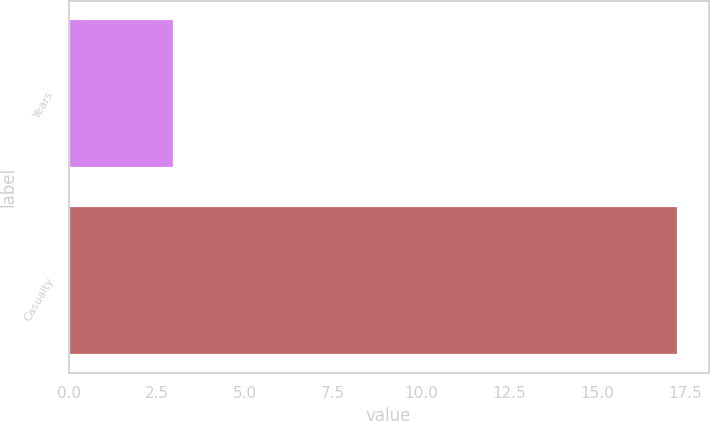Convert chart to OTSL. <chart><loc_0><loc_0><loc_500><loc_500><bar_chart><fcel>Years<fcel>Casualty<nl><fcel>3<fcel>17.3<nl></chart> 